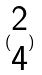<formula> <loc_0><loc_0><loc_500><loc_500>( \begin{matrix} 2 \\ 4 \end{matrix} )</formula> 